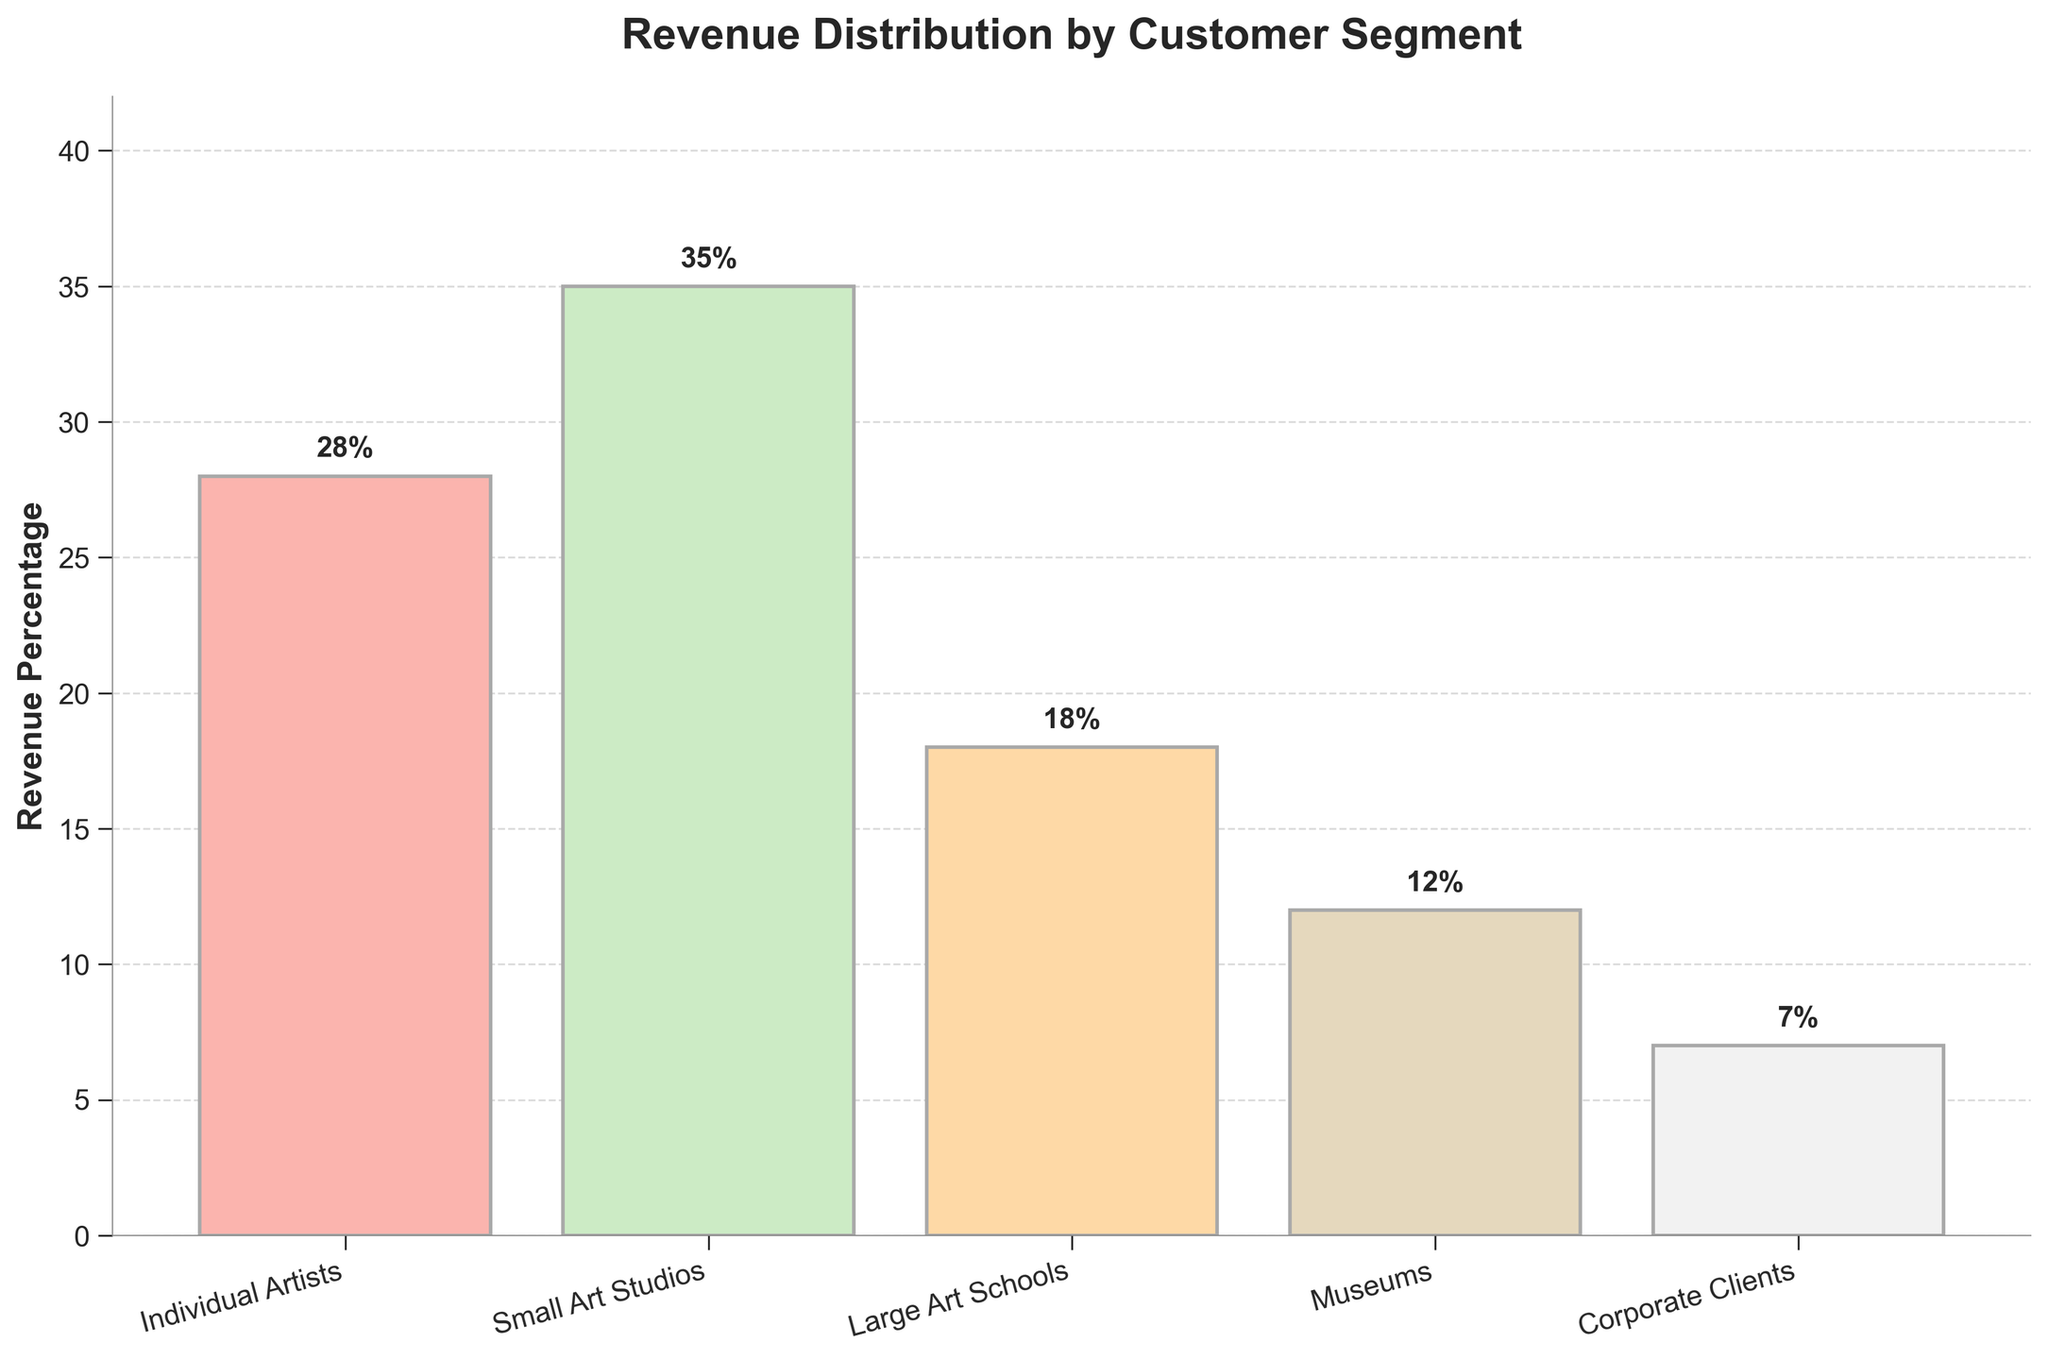Which customer segment generates the highest percentage of revenue? By looking at the height of the bars, Small Art Studios have the highest bar, representing 35%.
Answer: Small Art Studios How much more revenue percentage do Individual Artists generate compared to Museums? Individual Artists generate 28% and Museums generate 12%. The difference is 28% - 12% = 16%.
Answer: 16% What is the combined revenue percentage of Small Art Studios and Large Art Schools? Small Art Studios generate 35% and Large Art Schools generate 18%. Sum them up: 35% + 18% = 53%.
Answer: 53% Which customer segment generates the least revenue and what percentage do they contribute? The bar representing Corporate Clients is the shortest, contributing 7%.
Answer: Corporate Clients, 7% What is the average revenue percentage across all customer segments? Sum all percentages: 28% + 35% + 18% + 12% + 7% = 100%. There are 5 segments, so the average is 100% / 5 = 20%.
Answer: 20% What is the difference in revenue percentage between the highest and lowest generating segments? The highest segment is Small Art Studios at 35%, and the lowest is Corporate Clients at 7%. The difference is 35% - 7% = 28%.
Answer: 28% By how much does the revenue percentage from Large Art Schools exceed that from Corporate Clients? Large Art Schools generate 18% and Corporate Clients generate 7%. The difference is 18% - 7% = 11%.
Answer: 11% What is the collective revenue percentage of all segments excluding Small Art Studios? Excluding Small Art Studios (35%), sum the rest: 28% + 18% + 12% + 7% = 65%.
Answer: 65% How many customer segments generate a revenue percentage higher than 10%? Individual Artists (28%), Small Art Studios (35%), and Large Art Schools (18%), and Museums (12%) all generate more than 10%. That's 4 segments.
Answer: 4 Which segment has a revenue percentage closest to the average revenue percentage of all segments? The average is 20%. Comparing each: Individual Artists (28%), Small Art Studios (35%), Large Art Schools (18%), Museums (12%), and Corporate Clients (7%). 18% (Large Art Schools) is closest to 20%.
Answer: Large Art Schools 